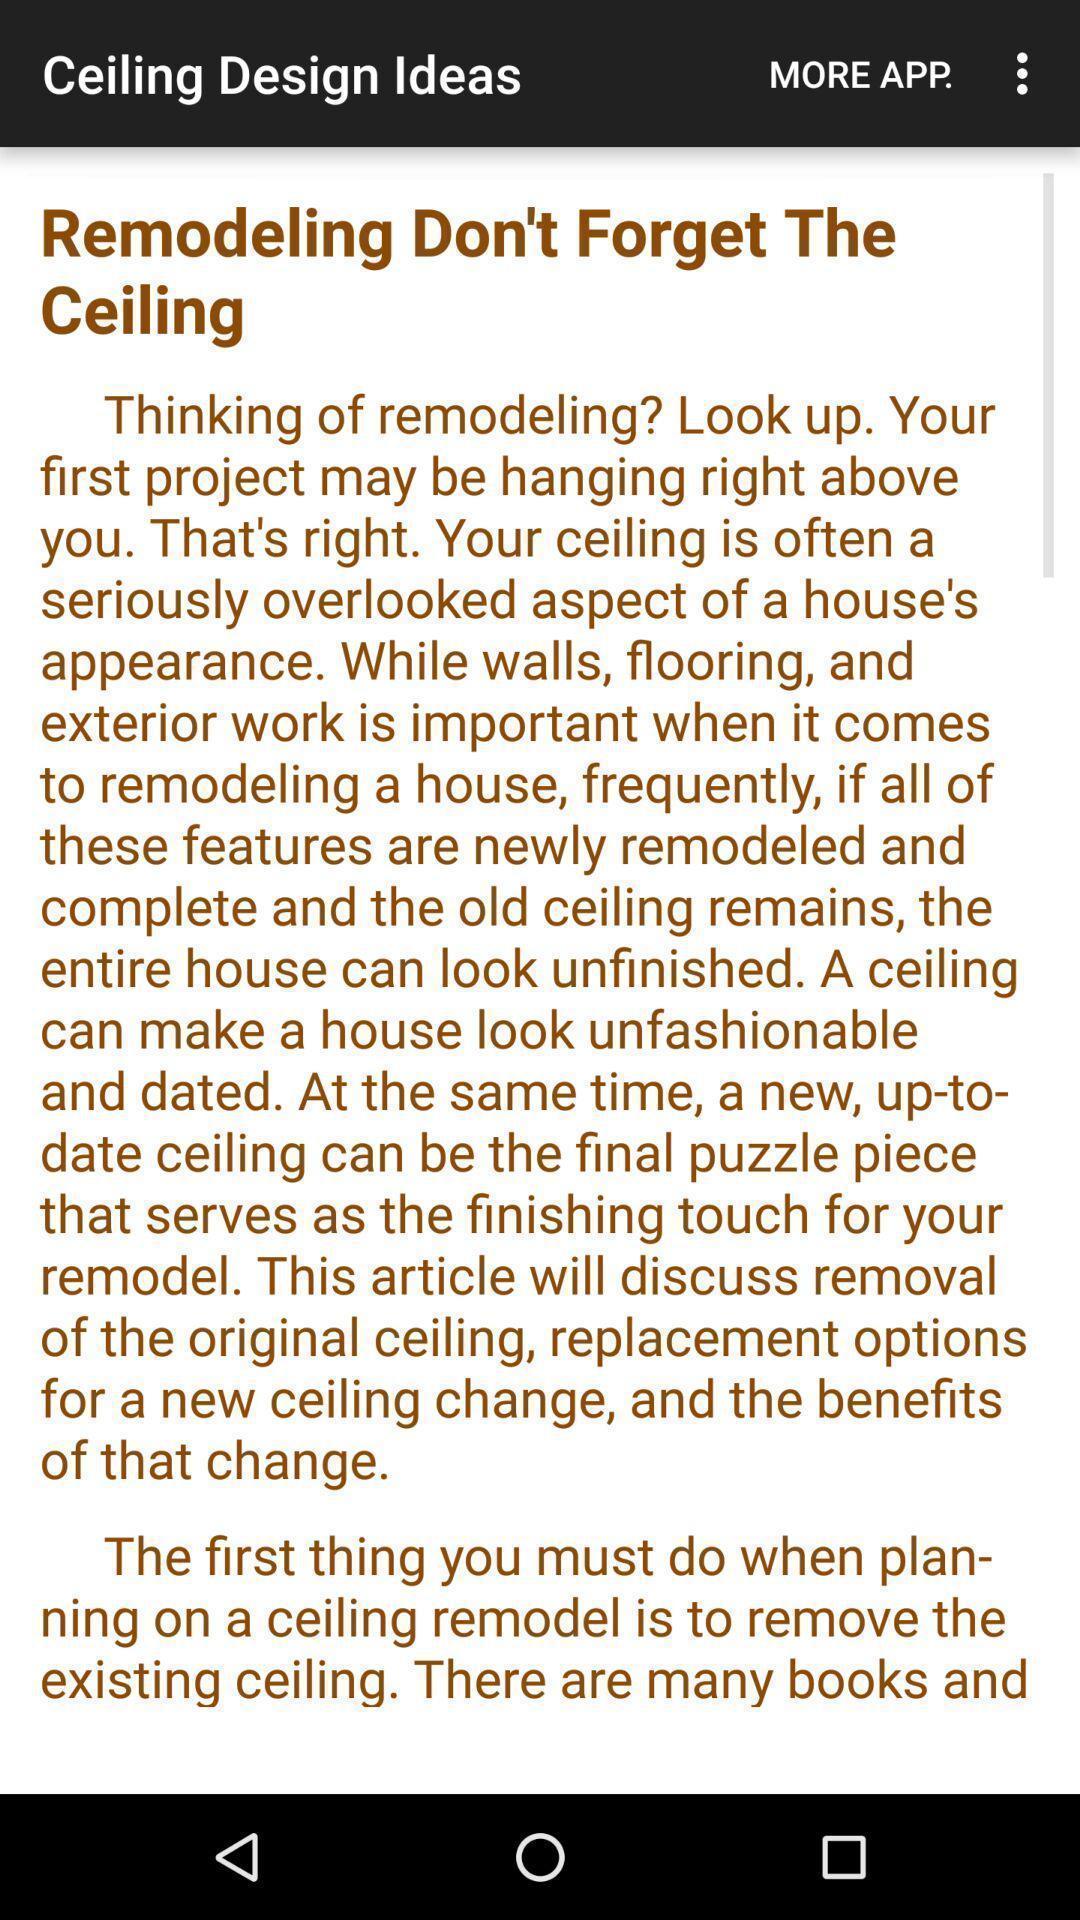Explain the elements present in this screenshot. Screen displaying the page of a design app. 